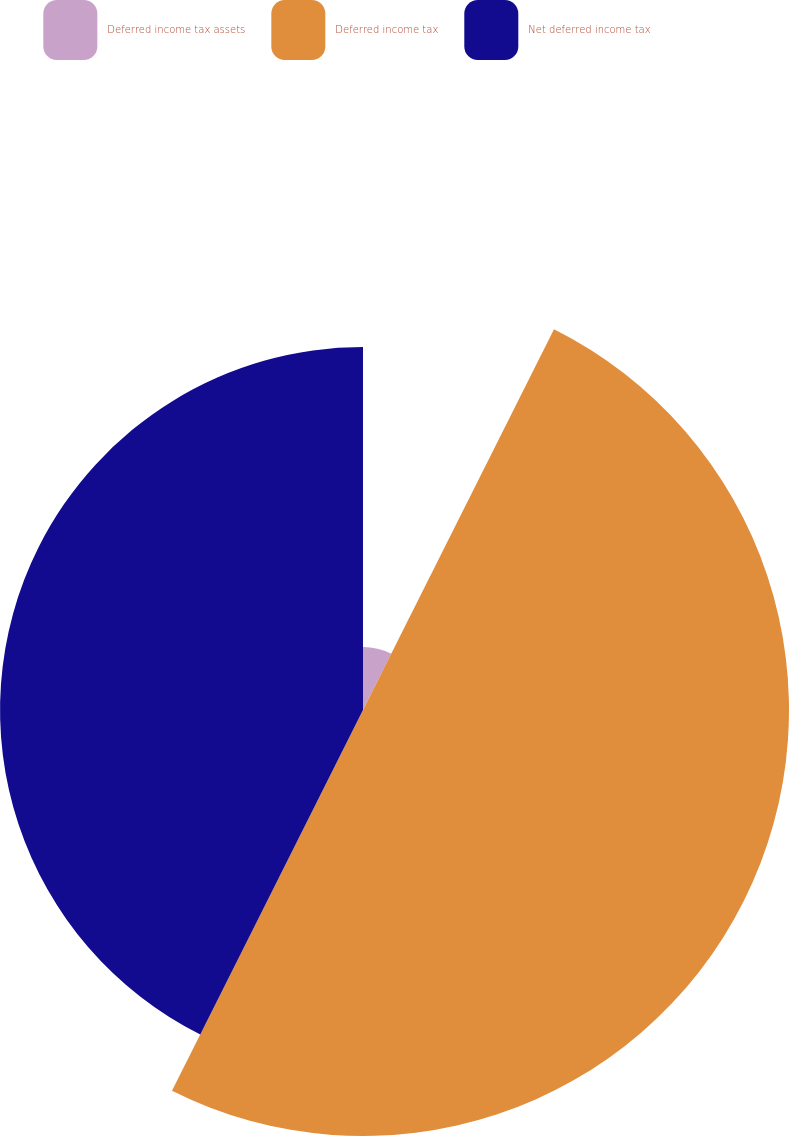<chart> <loc_0><loc_0><loc_500><loc_500><pie_chart><fcel>Deferred income tax assets<fcel>Deferred income tax<fcel>Net deferred income tax<nl><fcel>7.4%<fcel>50.0%<fcel>42.6%<nl></chart> 